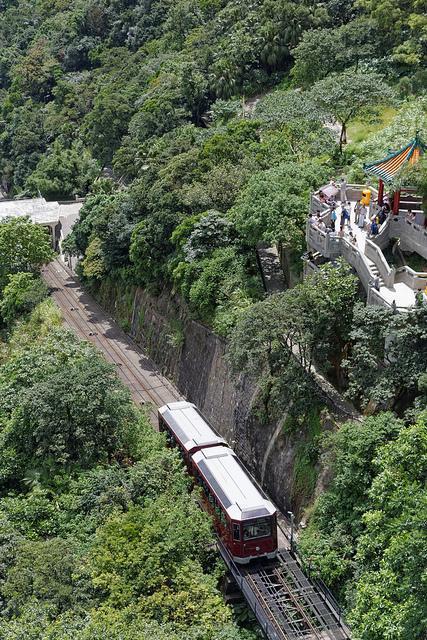How many cars are on this train?
Give a very brief answer. 2. How many people are in this photo?
Give a very brief answer. 0. How many train cars are there?
Give a very brief answer. 2. 